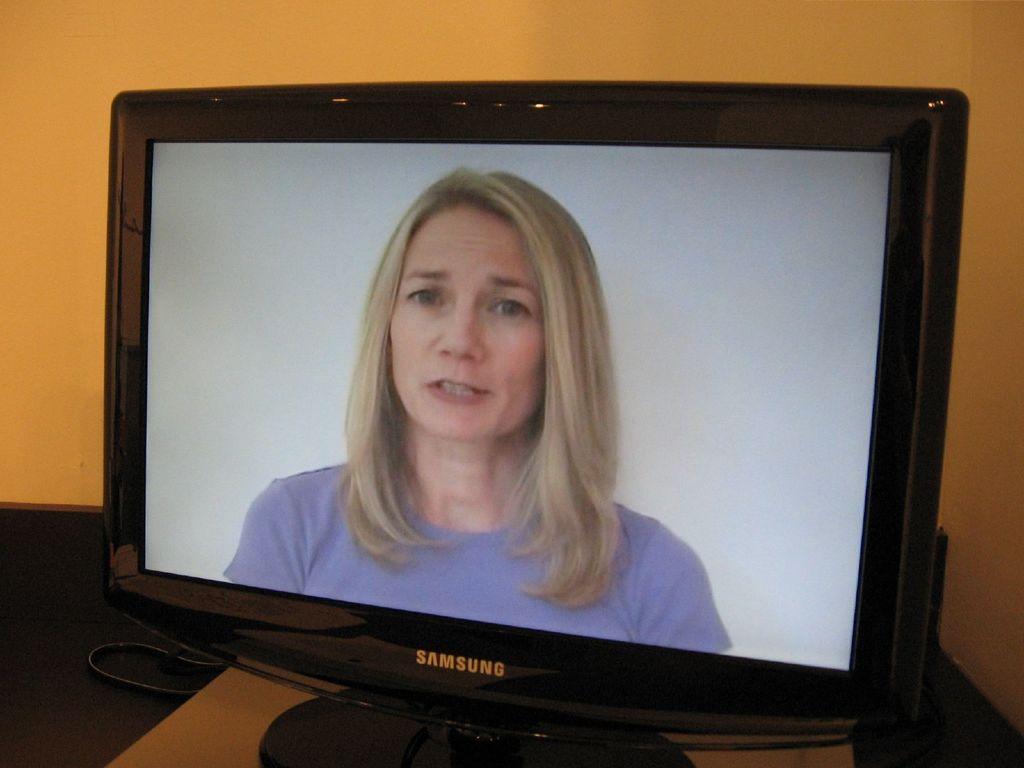What brand of monitor is this?
Offer a very short reply. Samsung. 